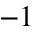Convert formula to latex. <formula><loc_0><loc_0><loc_500><loc_500>^ { - 1 }</formula> 